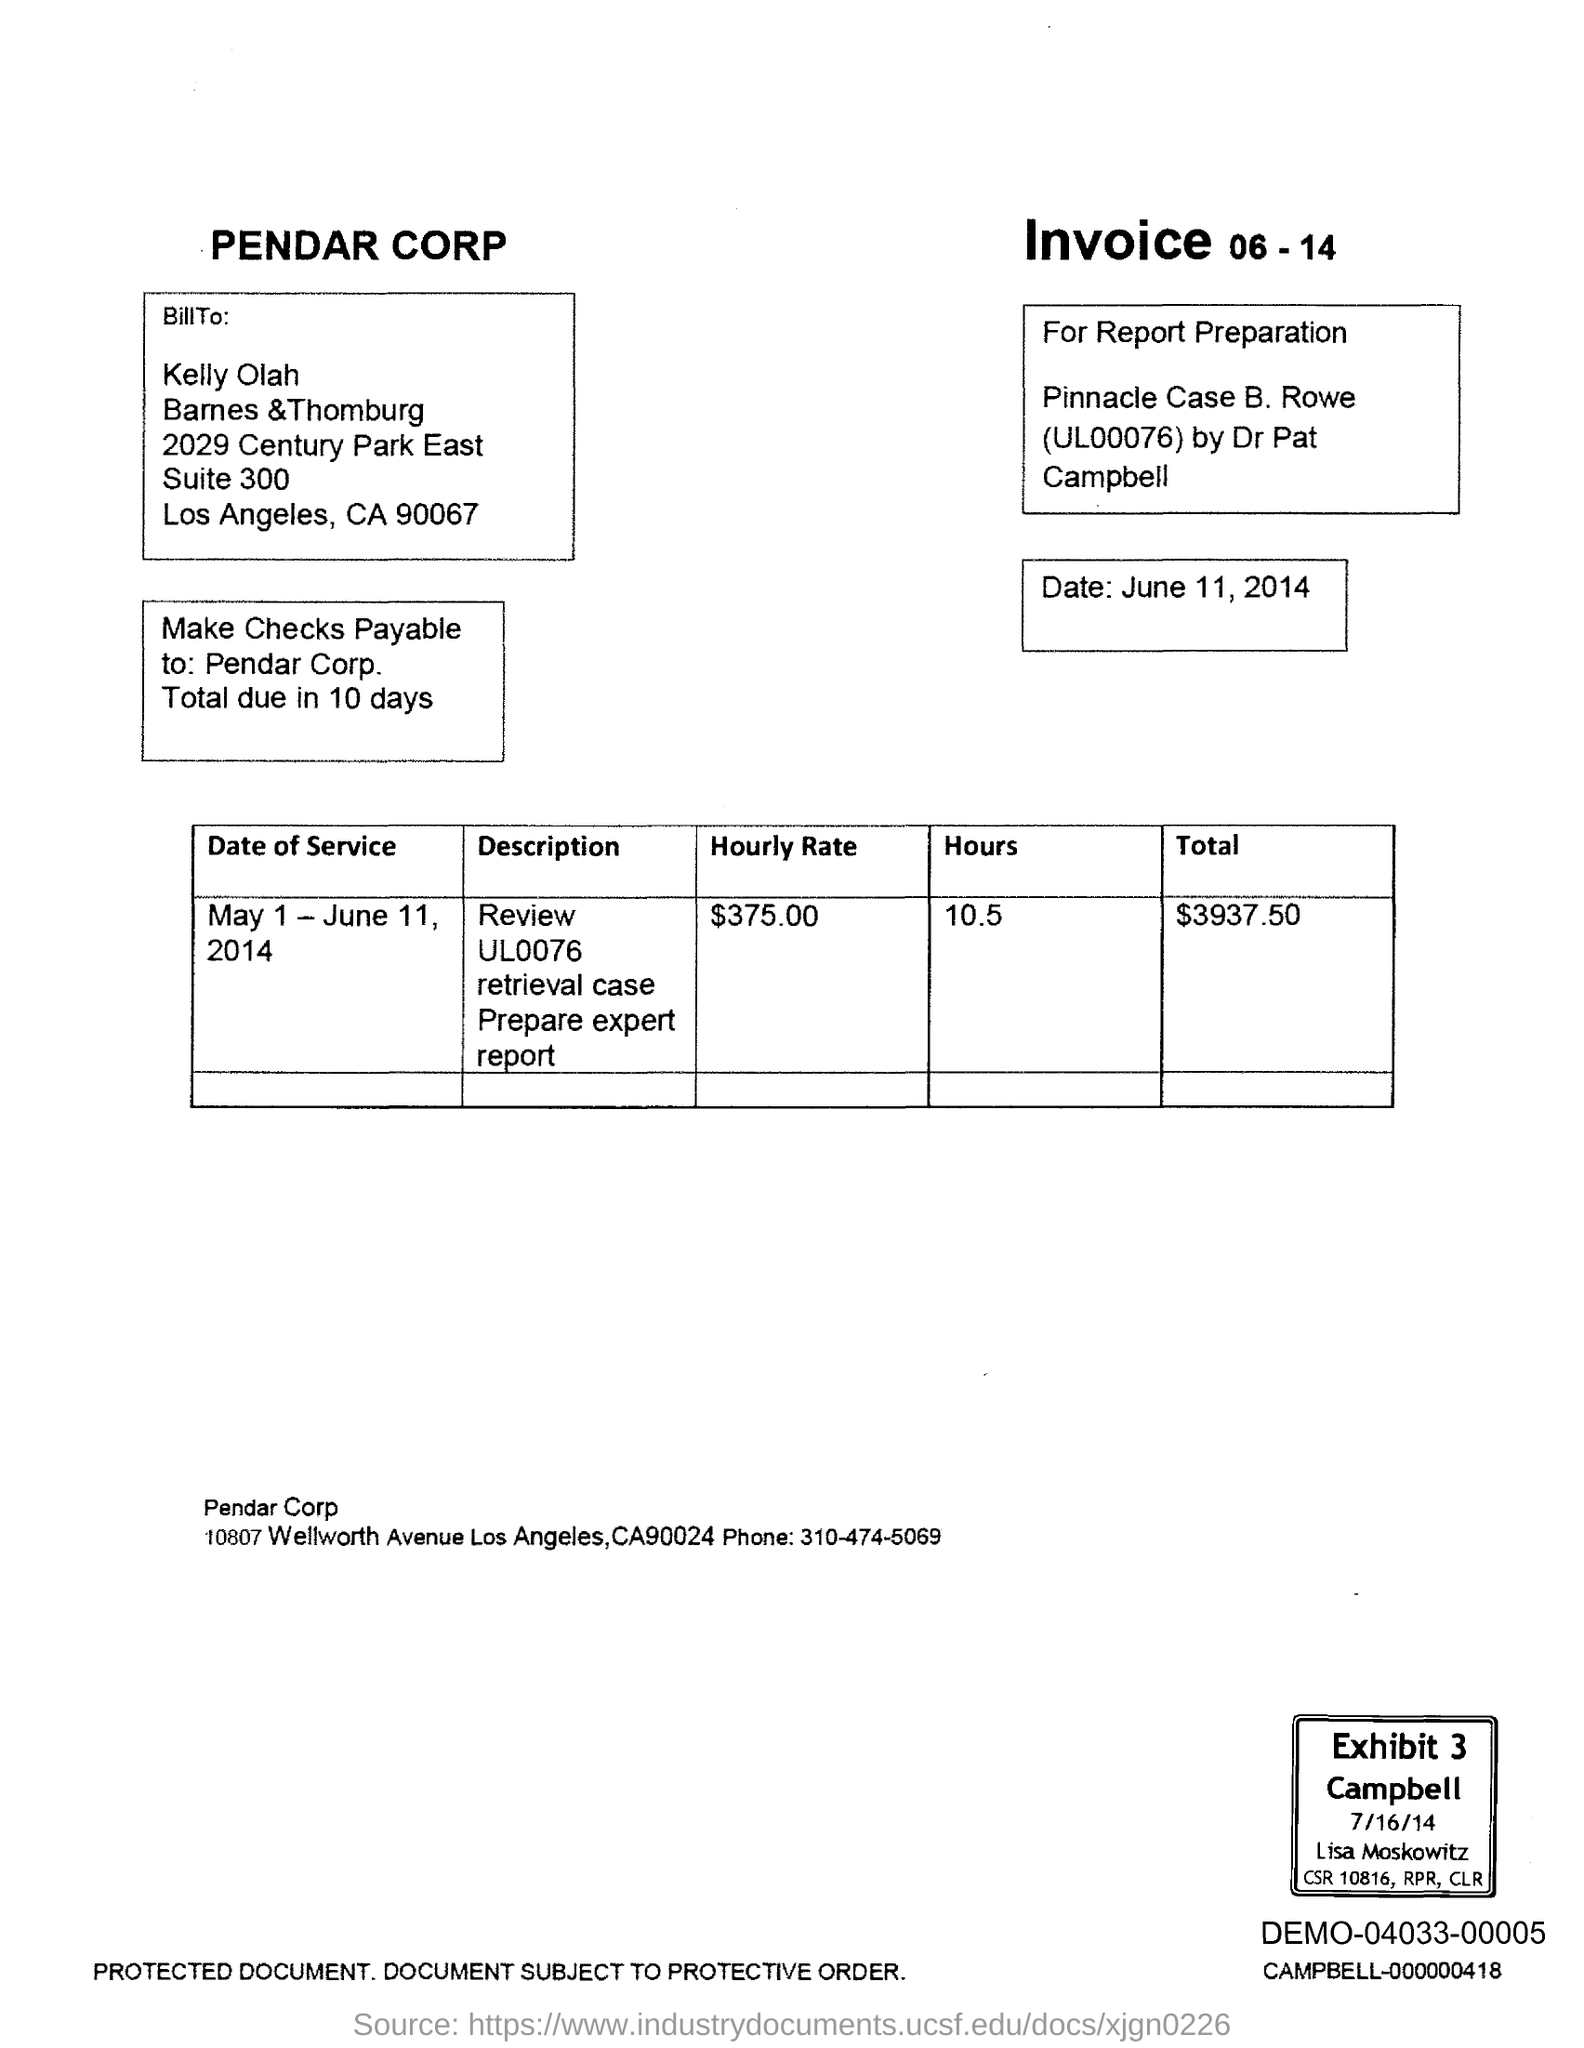Who is the "Bill To"?
Your answer should be compact. Kelly Olah. What is the Date?
Offer a very short reply. June 11, 2014. Make checks payable to whom?
Make the answer very short. Pendar Corp. What is the date of service?
Your response must be concise. May 1 - June 11, 2014. What is the Hourly Rate?
Offer a terse response. $375.00. What are the hours?
Ensure brevity in your answer.  10.5. What is the Total?
Ensure brevity in your answer.  $3937.50. 